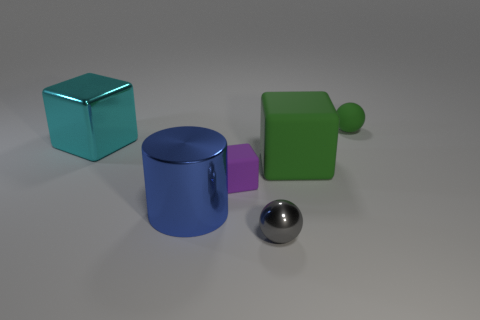The sphere that is the same color as the large rubber block is what size? The sphere shares its color with the large rubber block, which suggests they are both green. Considering the relative sizes of objects in the image, the sphere is small in comparison to the other figures. 